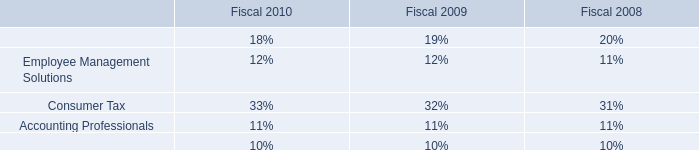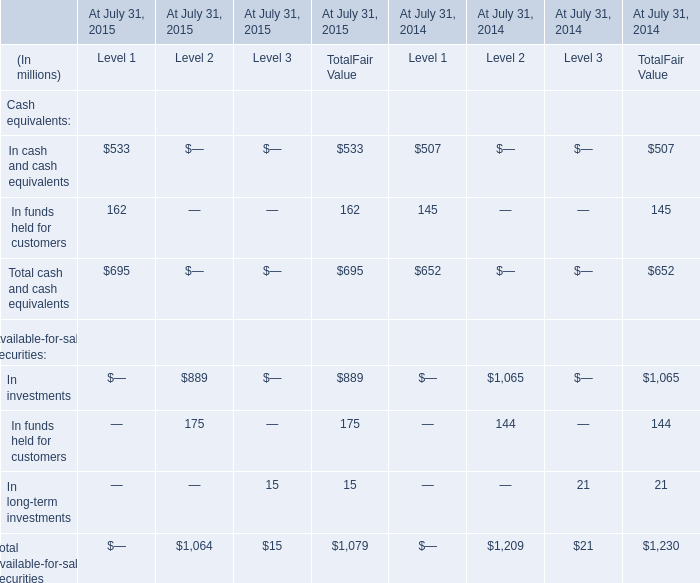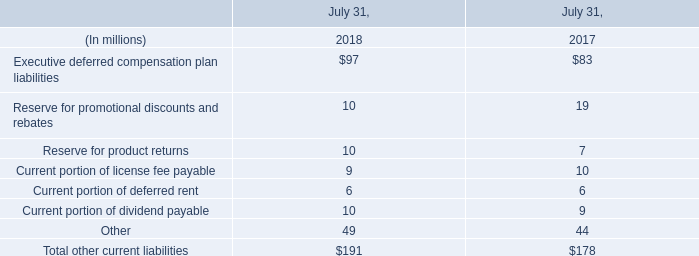At July 31,what year is Total Fair Value of Total available-for-sale securities less? 
Answer: 2015. 